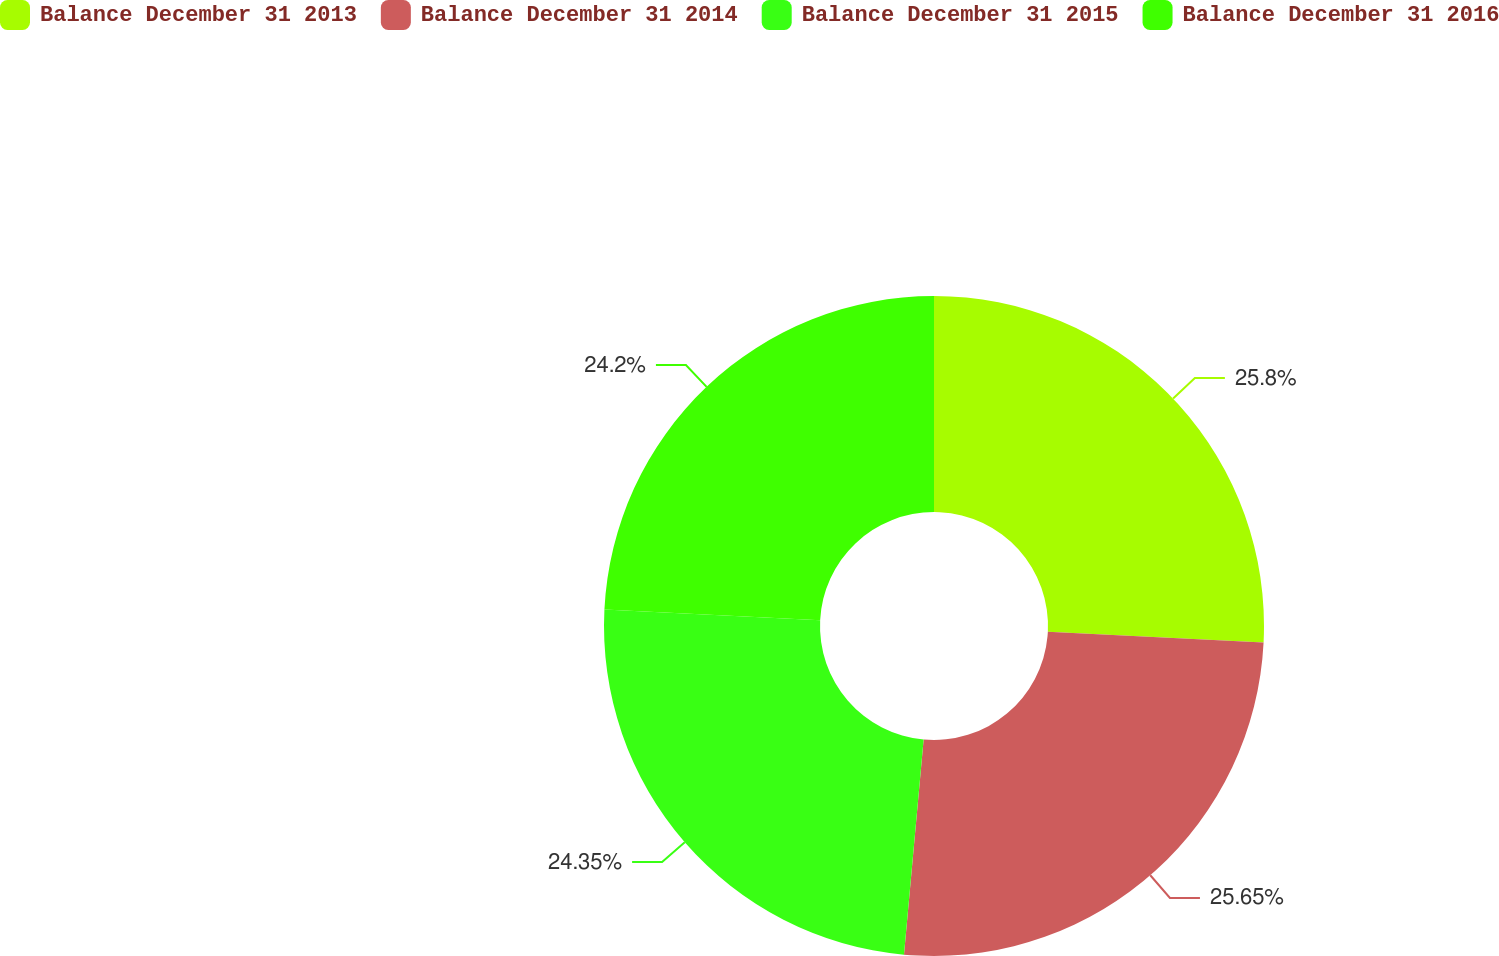Convert chart to OTSL. <chart><loc_0><loc_0><loc_500><loc_500><pie_chart><fcel>Balance December 31 2013<fcel>Balance December 31 2014<fcel>Balance December 31 2015<fcel>Balance December 31 2016<nl><fcel>25.8%<fcel>25.65%<fcel>24.35%<fcel>24.2%<nl></chart> 